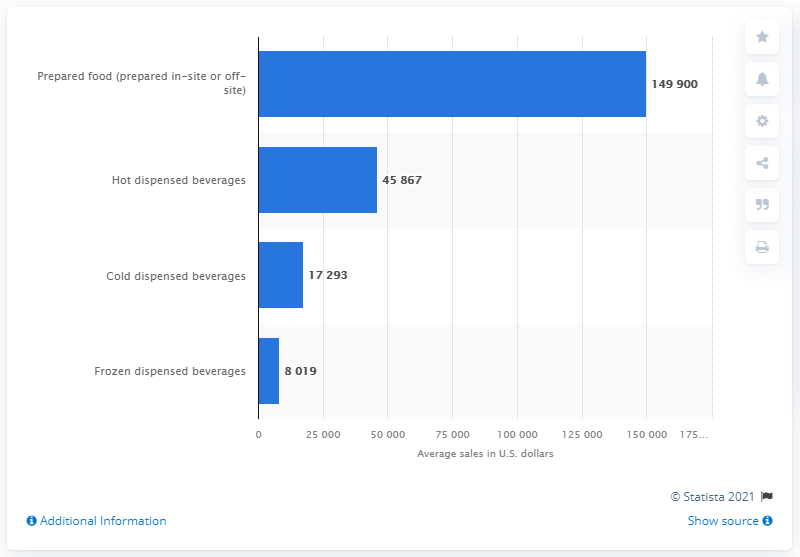Give some essential details in this illustration. In the United States in 2015, hot dispensed beverages generated approximately 45,867 dollars. 